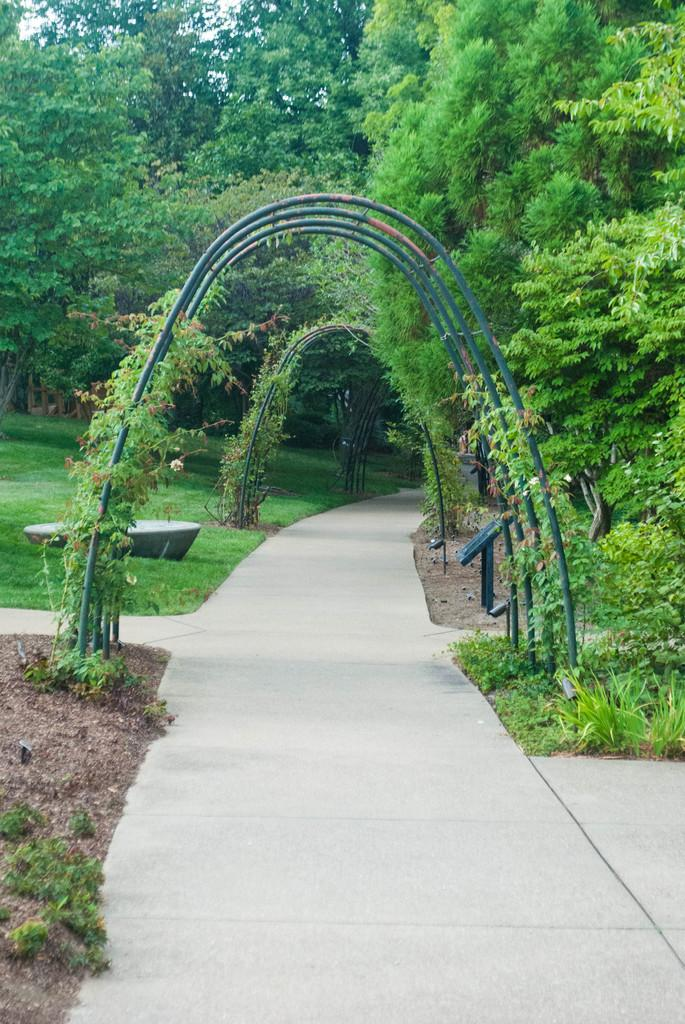What type of vegetation can be seen in the image? There are trees in the image. What is covering the ground in the image? There is grass on the ground in the image. Is there a designated area for walking in the image? Yes, there is a path to walk in the image. Where is the cave located in the image? There is no cave present in the image. Whose birthday is being celebrated in the image? There is no indication of a birthday celebration in the image. 